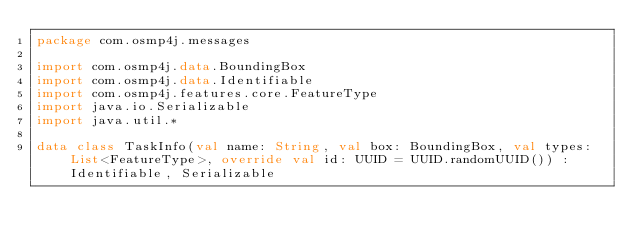Convert code to text. <code><loc_0><loc_0><loc_500><loc_500><_Kotlin_>package com.osmp4j.messages

import com.osmp4j.data.BoundingBox
import com.osmp4j.data.Identifiable
import com.osmp4j.features.core.FeatureType
import java.io.Serializable
import java.util.*

data class TaskInfo(val name: String, val box: BoundingBox, val types: List<FeatureType>, override val id: UUID = UUID.randomUUID()) : Identifiable, Serializable</code> 